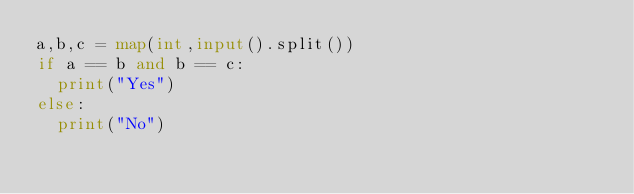Convert code to text. <code><loc_0><loc_0><loc_500><loc_500><_Python_>a,b,c = map(int,input().split())
if a == b and b == c:
  print("Yes")
else:
  print("No")</code> 